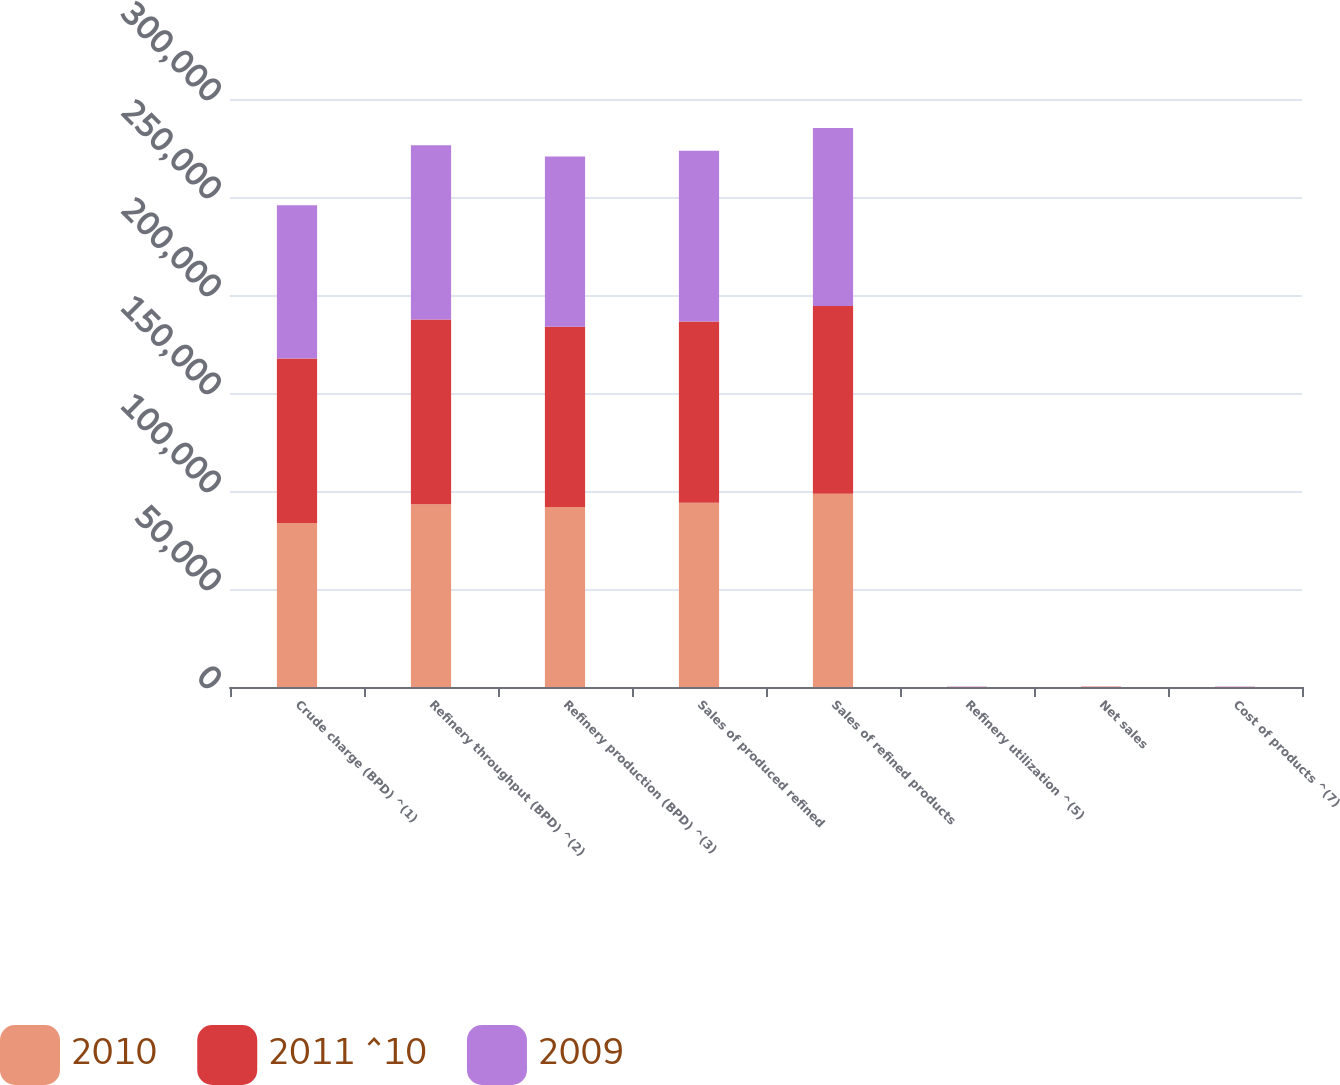<chart> <loc_0><loc_0><loc_500><loc_500><stacked_bar_chart><ecel><fcel>Crude charge (BPD) ^(1)<fcel>Refinery throughput (BPD) ^(2)<fcel>Refinery production (BPD) ^(3)<fcel>Sales of produced refined<fcel>Sales of refined products<fcel>Refinery utilization ^(5)<fcel>Net sales<fcel>Cost of products ^(7)<nl><fcel>2010<fcel>83700<fcel>93260<fcel>91810<fcel>93950<fcel>98540<fcel>83.7<fcel>118.76<fcel>98.4<nl><fcel>2011 ^10<fcel>83900<fcel>94270<fcel>92050<fcel>92550<fcel>95790<fcel>83.9<fcel>90.37<fcel>83.12<nl><fcel>2009<fcel>78160<fcel>88900<fcel>86760<fcel>87140<fcel>90870<fcel>81.2<fcel>73.15<fcel>65.95<nl></chart> 